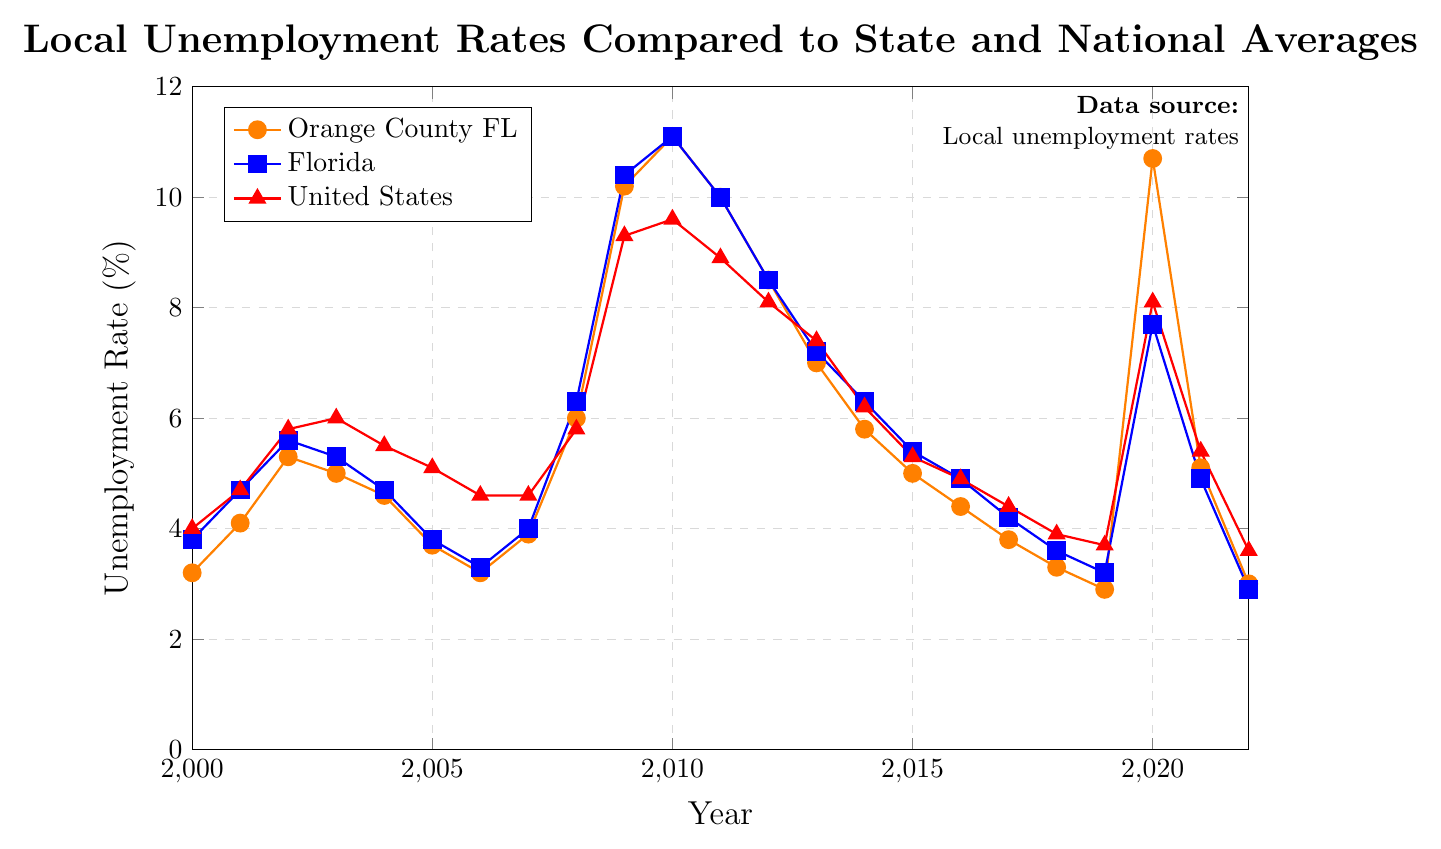What year did Orange County, FL, have the highest unemployment rate? Refer to the line representing Orange County, FL. The highest point corresponds to the year 2010.
Answer: 2010 Compare the unemployment rate of Orange County, FL, and the United States in 2020. Which was higher? Locate the two points for the year 2020 on the lines representing Orange County, FL, and the United States. Orange County, FL, has an unemployment rate of 10.7%, while the United States has an unemployment rate of 8.1%.
Answer: Orange County, FL What was the minimum unemployment rate for Florida from 2000 to present? Identify the lowest point on the line representing Florida. The minimum unemployment rate was 2.9% in 2022.
Answer: 2.9% By how much did the unemployment rate in Orange County, FL, decrease between 2010 and 2022? Find the unemployment rates for Orange County, FL, in 2010 (11.1%) and in 2022 (3.0%). Subtract the 2022 rate from the 2010 rate: 11.1% - 3.0%.
Answer: 8.1% During which years did Orange County, FL, have a higher unemployment rate than the national average? Compare the heights of the lines representing Orange County, FL, and the United States for each year and note the years where Orange County's rate is higher. The relevant years are 2000, 2001, 2003, 2018, 2019, and 2020.
Answer: 2000, 2001, 2003, 2018, 2019, 2020 What was the difference in unemployment rates between Florida and the United States in 2002? Identify the unemployment rates for Florida (5.6%) and the United States (5.8%) in 2002. Subtract the rate of Florida from the rate of the United States: 5.8% - 5.6%.
Answer: 0.2% How did the unemployment rates in Orange County, FL, change from 2008 to 2009? Find the rates for Orange County, FL, in 2008 (6.0%) and in 2009 (10.2%), then calculate the difference: 10.2% - 6.0%.
Answer: Increased by 4.2% Which region showed the largest increase in unemployment rate from 2019 to 2020? Compare the changes in unemployment rates from 2019 to 2020 for Orange County, FL (2.9% to 10.7%), Florida (3.2% to 7.7%), and the United States (3.7% to 8.1%). Orange County, FL, has the largest increase.
Answer: Orange County, FL How did the unemployment rate in Florida compare to the national average in 2017? Find the unemployment rates for Florida (4.2%) and the national average (4.4%) in 2017.
Answer: Florida was 0.2% lower than the national average What is the overall trend for unemployment rates in Orange County, FL, from 2011 to 2019? Observe the line representing Orange County, FL, from 2011 (10.0%) to 2019 (2.9%). The line shows a general decreasing trend.
Answer: Decreasing trend 